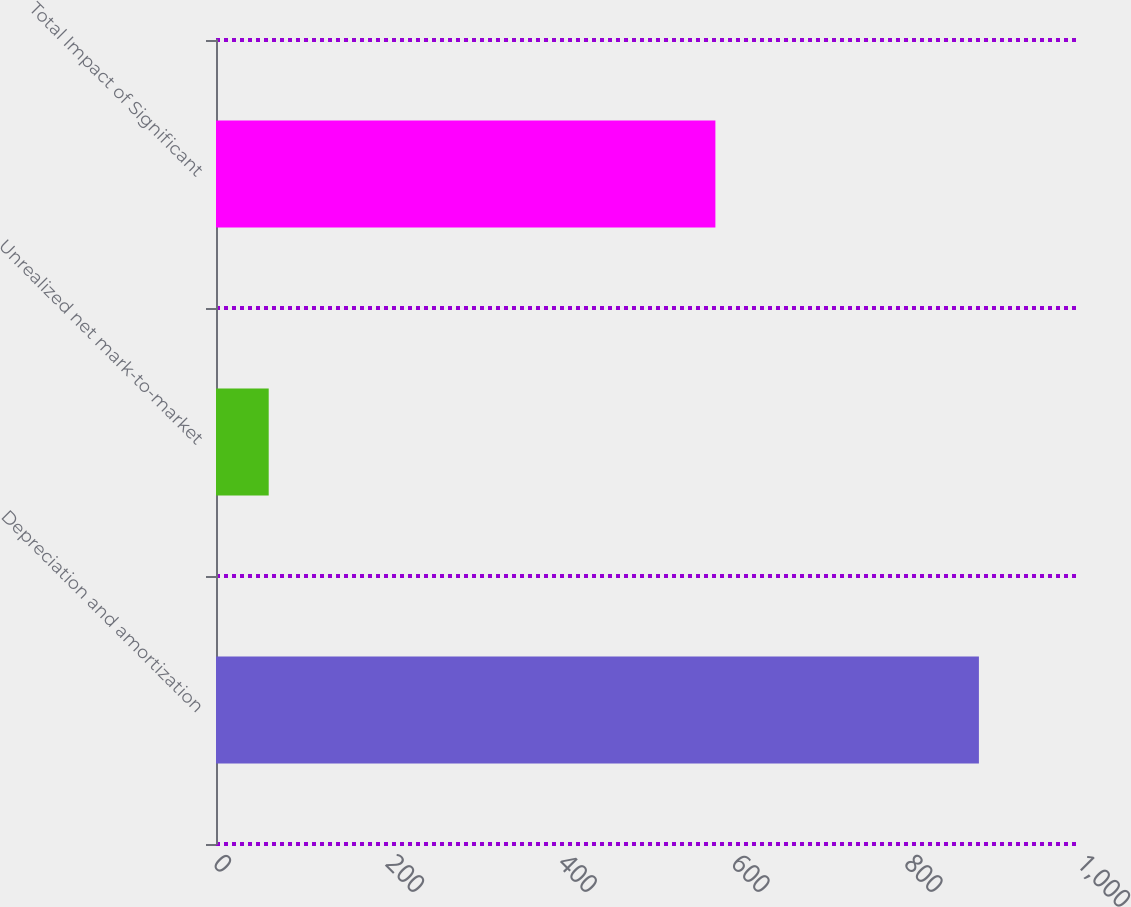<chart> <loc_0><loc_0><loc_500><loc_500><bar_chart><fcel>Depreciation and amortization<fcel>Unrealized net mark-to-market<fcel>Total Impact of Significant<nl><fcel>883<fcel>61<fcel>578<nl></chart> 